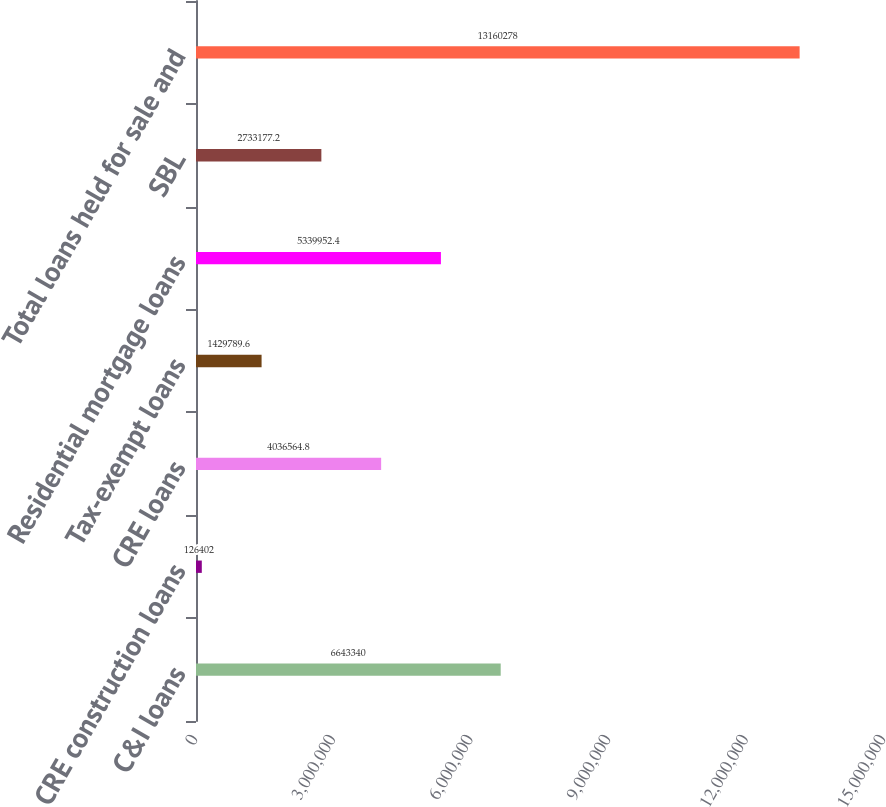Convert chart. <chart><loc_0><loc_0><loc_500><loc_500><bar_chart><fcel>C&I loans<fcel>CRE construction loans<fcel>CRE loans<fcel>Tax-exempt loans<fcel>Residential mortgage loans<fcel>SBL<fcel>Total loans held for sale and<nl><fcel>6.64334e+06<fcel>126402<fcel>4.03656e+06<fcel>1.42979e+06<fcel>5.33995e+06<fcel>2.73318e+06<fcel>1.31603e+07<nl></chart> 